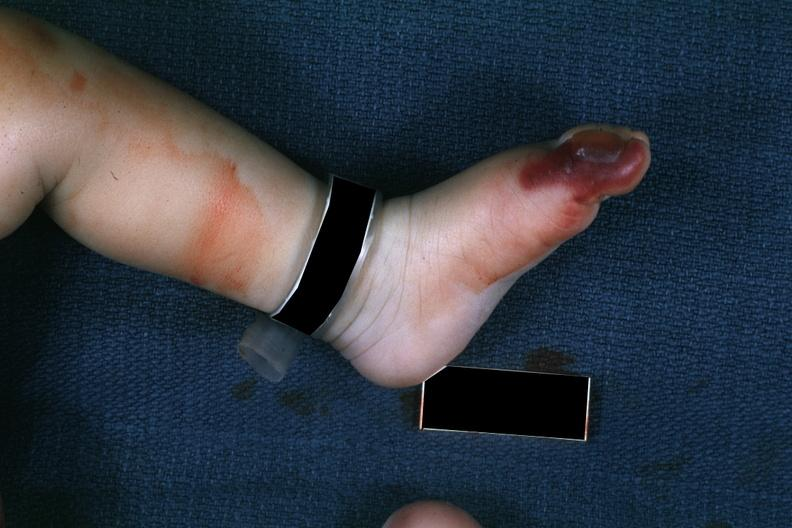what are present?
Answer the question using a single word or phrase. Extremities 